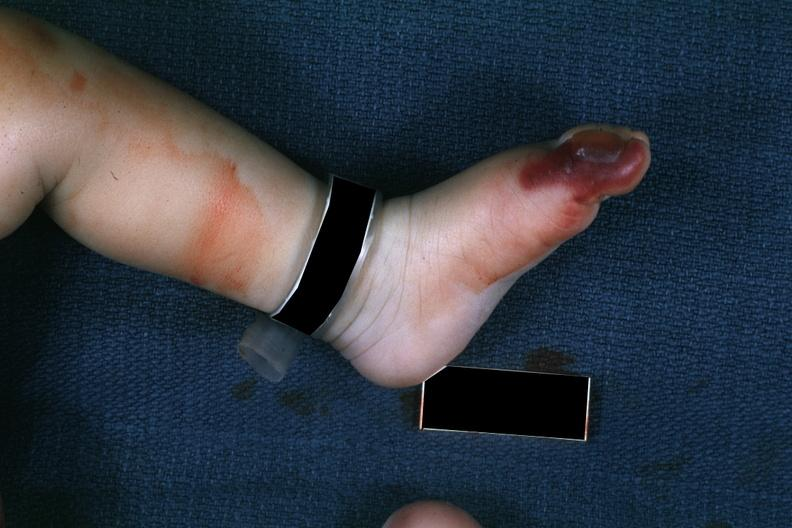what are present?
Answer the question using a single word or phrase. Extremities 